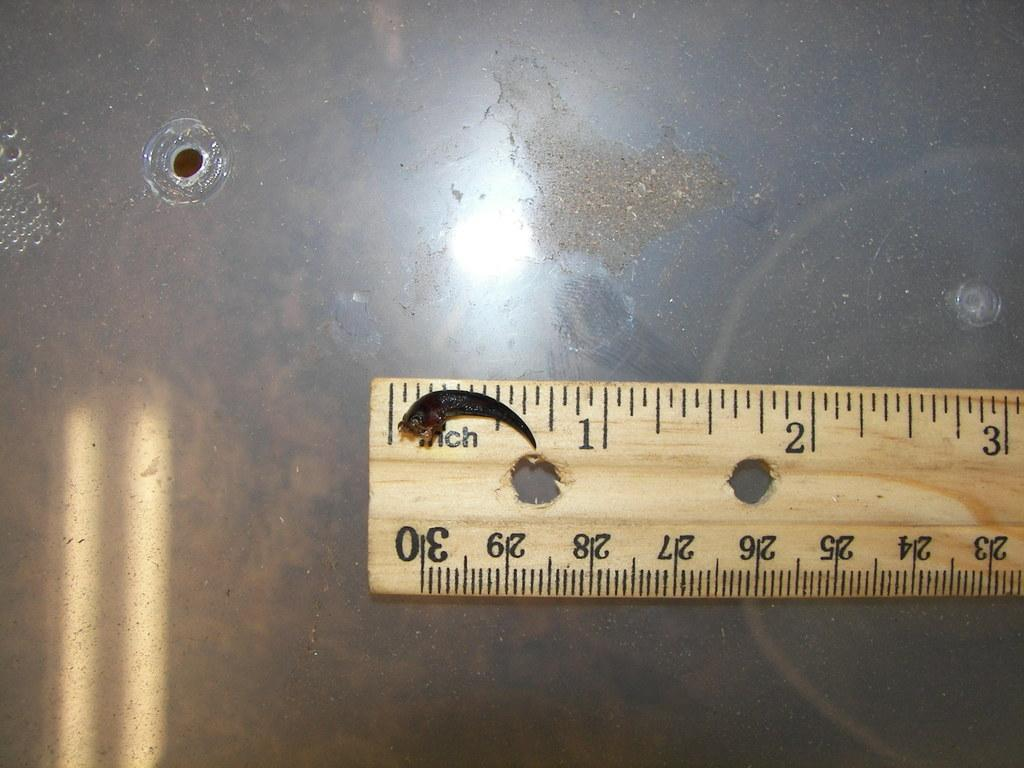<image>
Render a clear and concise summary of the photo. A claw sits on a measuring tape and it measures less than an inch. 